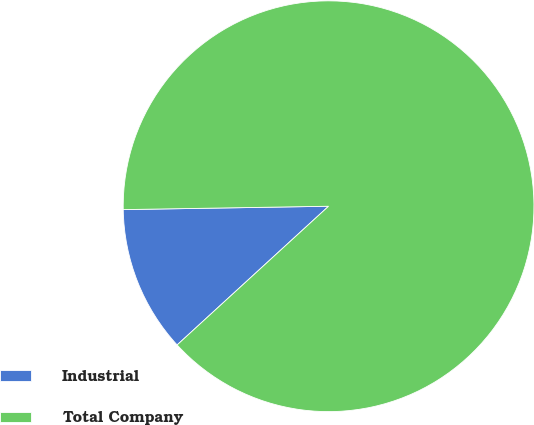Convert chart to OTSL. <chart><loc_0><loc_0><loc_500><loc_500><pie_chart><fcel>Industrial<fcel>Total Company<nl><fcel>11.54%<fcel>88.46%<nl></chart> 